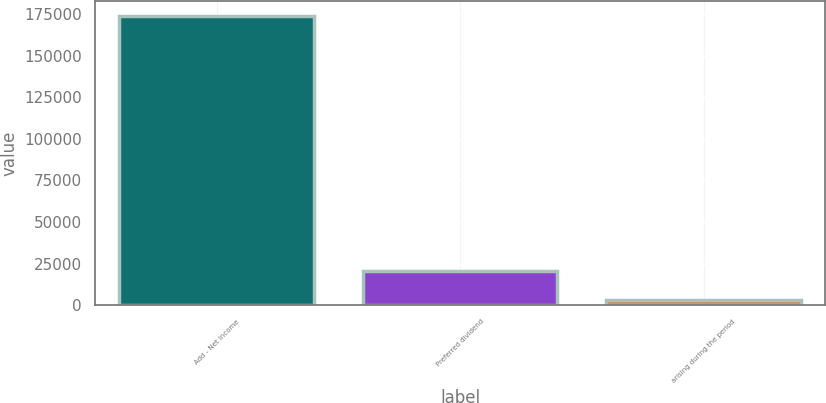Convert chart. <chart><loc_0><loc_0><loc_500><loc_500><bar_chart><fcel>Add - Net Income<fcel>Preferred dividend<fcel>arising during the period<nl><fcel>174078<fcel>20365.2<fcel>3286<nl></chart> 